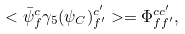Convert formula to latex. <formula><loc_0><loc_0><loc_500><loc_500>< \bar { \psi } _ { f } ^ { c } \gamma _ { 5 } ( \psi _ { C } ) _ { f ^ { \prime } } ^ { c ^ { \prime } } > = \Phi _ { f f ^ { \prime } } ^ { c c ^ { \prime } } ,</formula> 